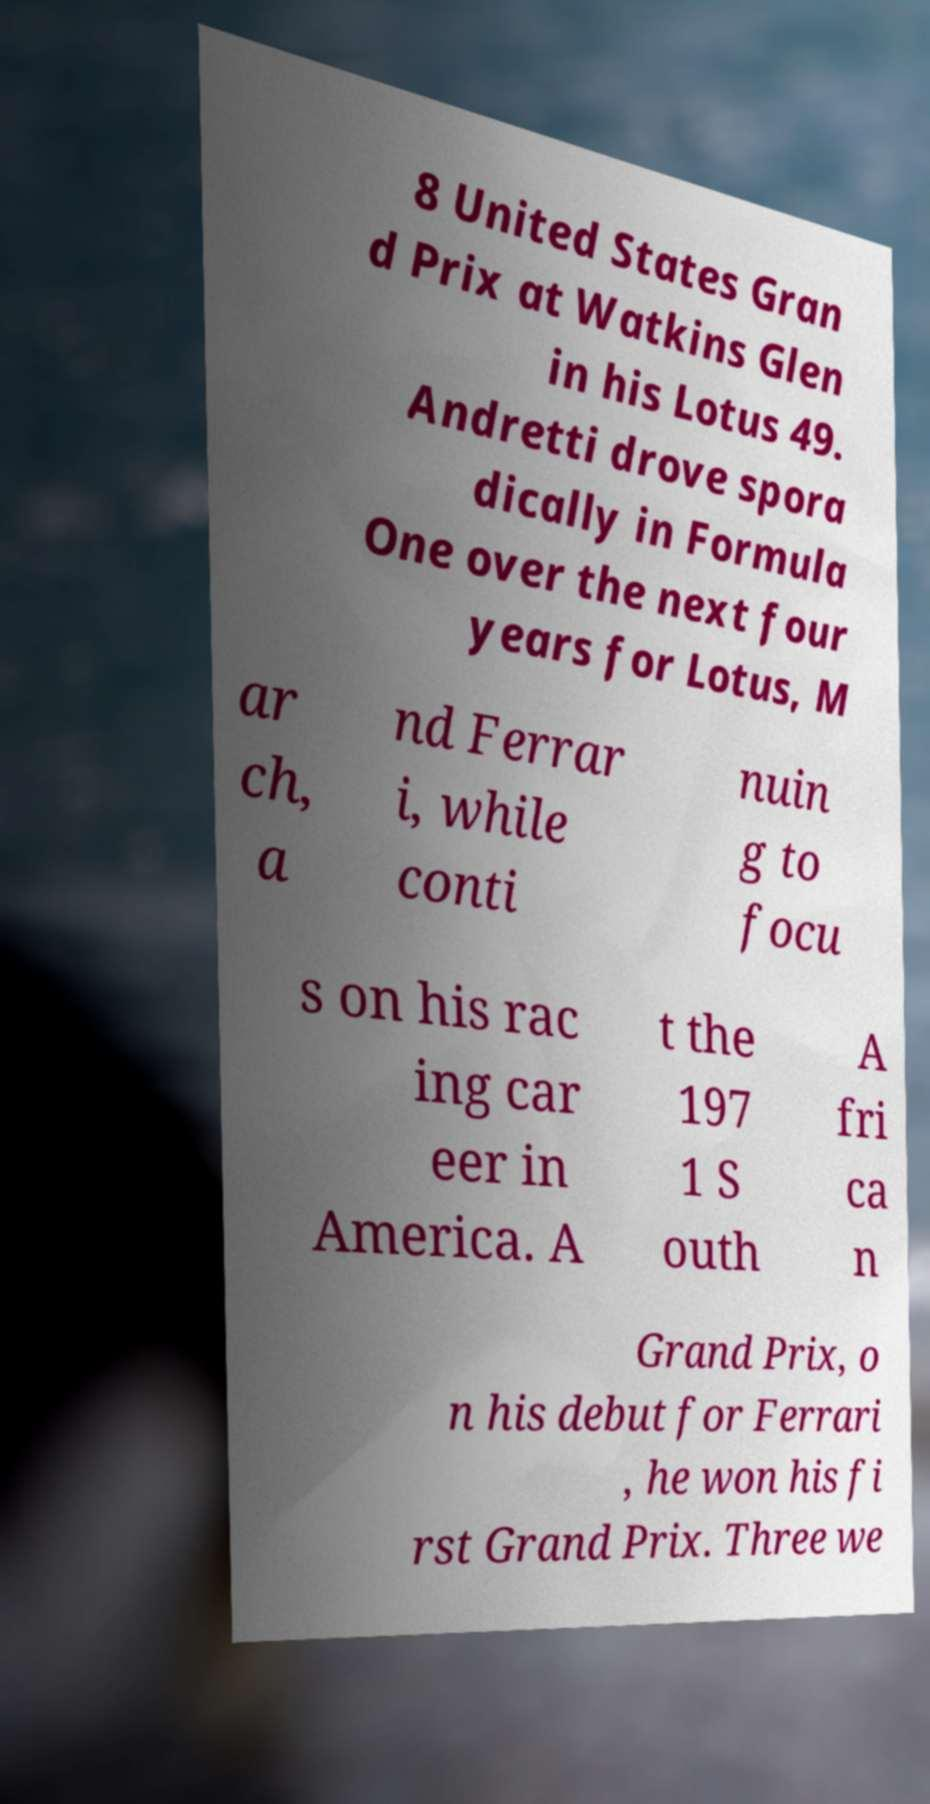What messages or text are displayed in this image? I need them in a readable, typed format. 8 United States Gran d Prix at Watkins Glen in his Lotus 49. Andretti drove spora dically in Formula One over the next four years for Lotus, M ar ch, a nd Ferrar i, while conti nuin g to focu s on his rac ing car eer in America. A t the 197 1 S outh A fri ca n Grand Prix, o n his debut for Ferrari , he won his fi rst Grand Prix. Three we 